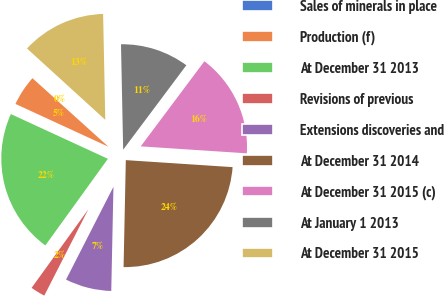<chart> <loc_0><loc_0><loc_500><loc_500><pie_chart><fcel>Sales of minerals in place<fcel>Production (f)<fcel>At December 31 2013<fcel>Revisions of previous<fcel>Extensions discoveries and<fcel>At December 31 2014<fcel>At December 31 2015 (c)<fcel>At January 1 2013<fcel>At December 31 2015<nl><fcel>0.08%<fcel>4.81%<fcel>21.92%<fcel>2.44%<fcel>7.18%<fcel>24.29%<fcel>15.82%<fcel>10.55%<fcel>12.91%<nl></chart> 